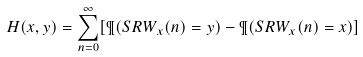<formula> <loc_0><loc_0><loc_500><loc_500>H ( x , y ) = \sum _ { n = 0 } ^ { \infty } [ \P ( S R W _ { x } ( n ) = y ) - \P ( S R W _ { x } ( n ) = x ) ]</formula> 